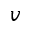<formula> <loc_0><loc_0><loc_500><loc_500>v</formula> 